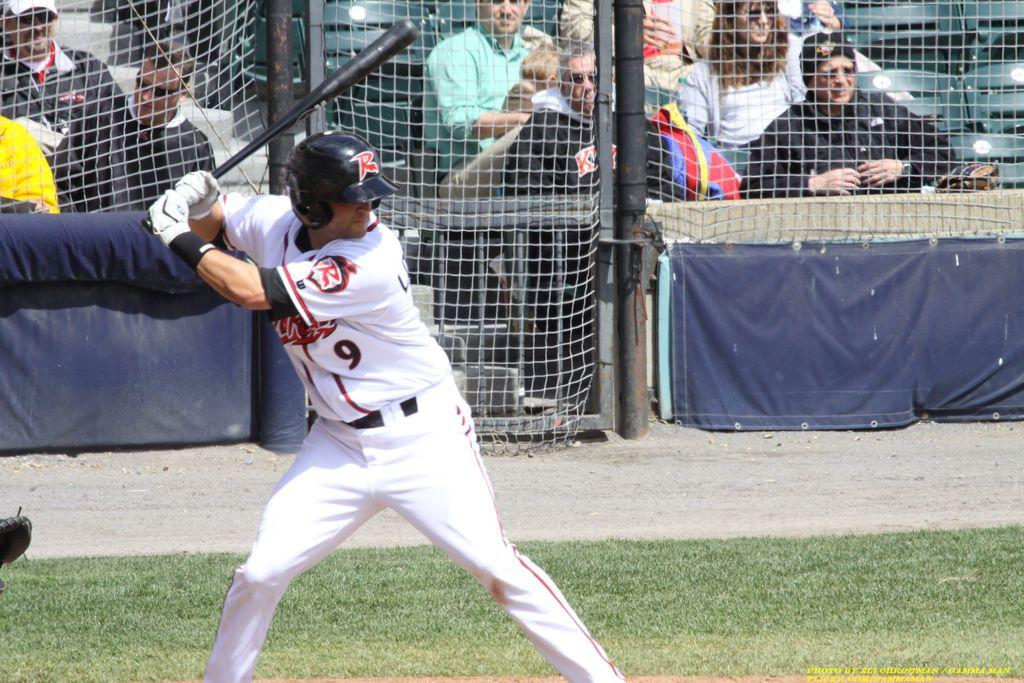<image>
Relay a brief, clear account of the picture shown. a baseball player up to bat in a 9 jersey 